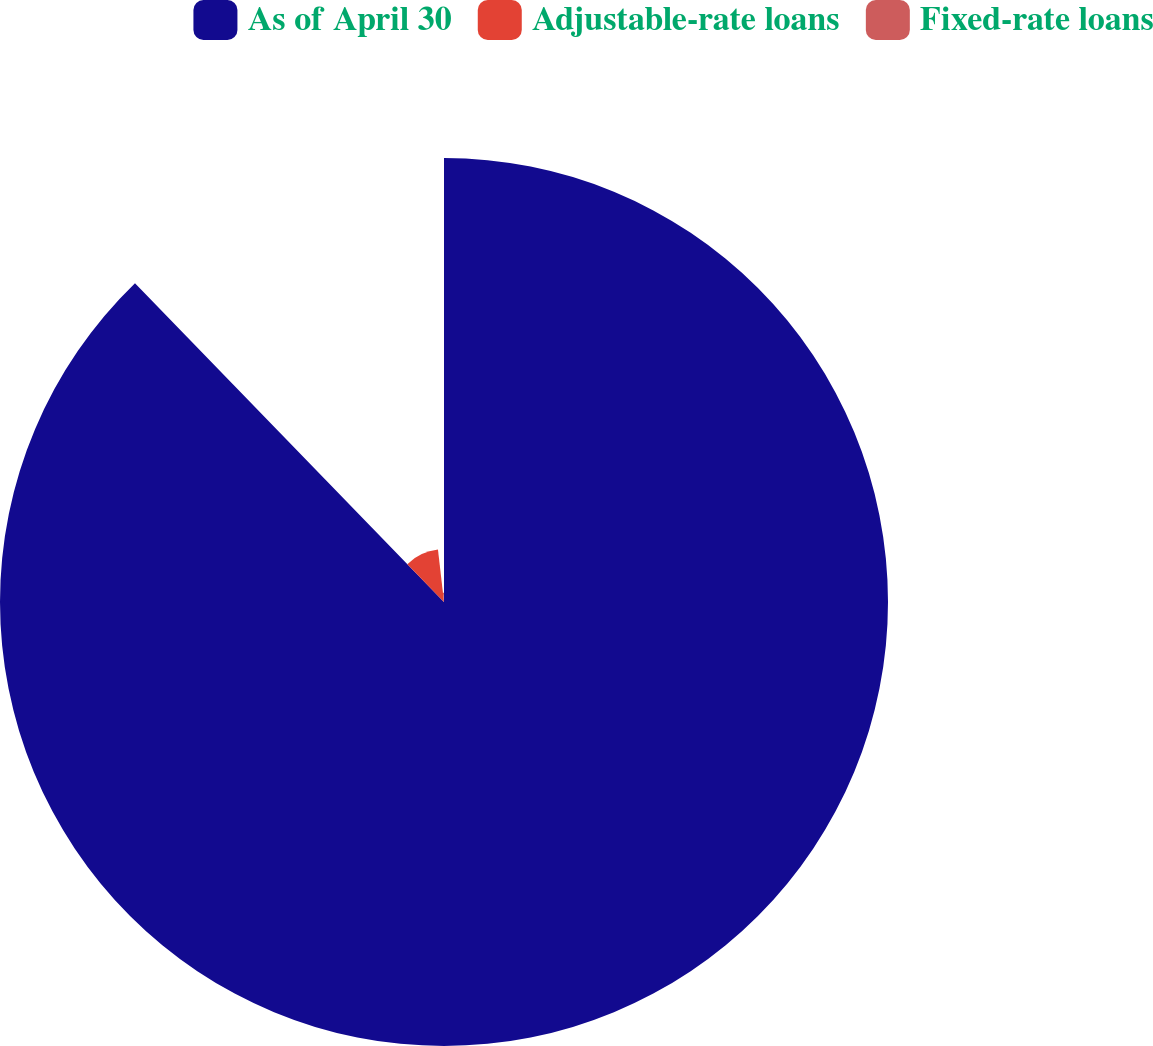Convert chart to OTSL. <chart><loc_0><loc_0><loc_500><loc_500><pie_chart><fcel>As of April 30<fcel>Adjustable-rate loans<fcel>Fixed-rate loans<nl><fcel>87.74%<fcel>10.42%<fcel>1.83%<nl></chart> 